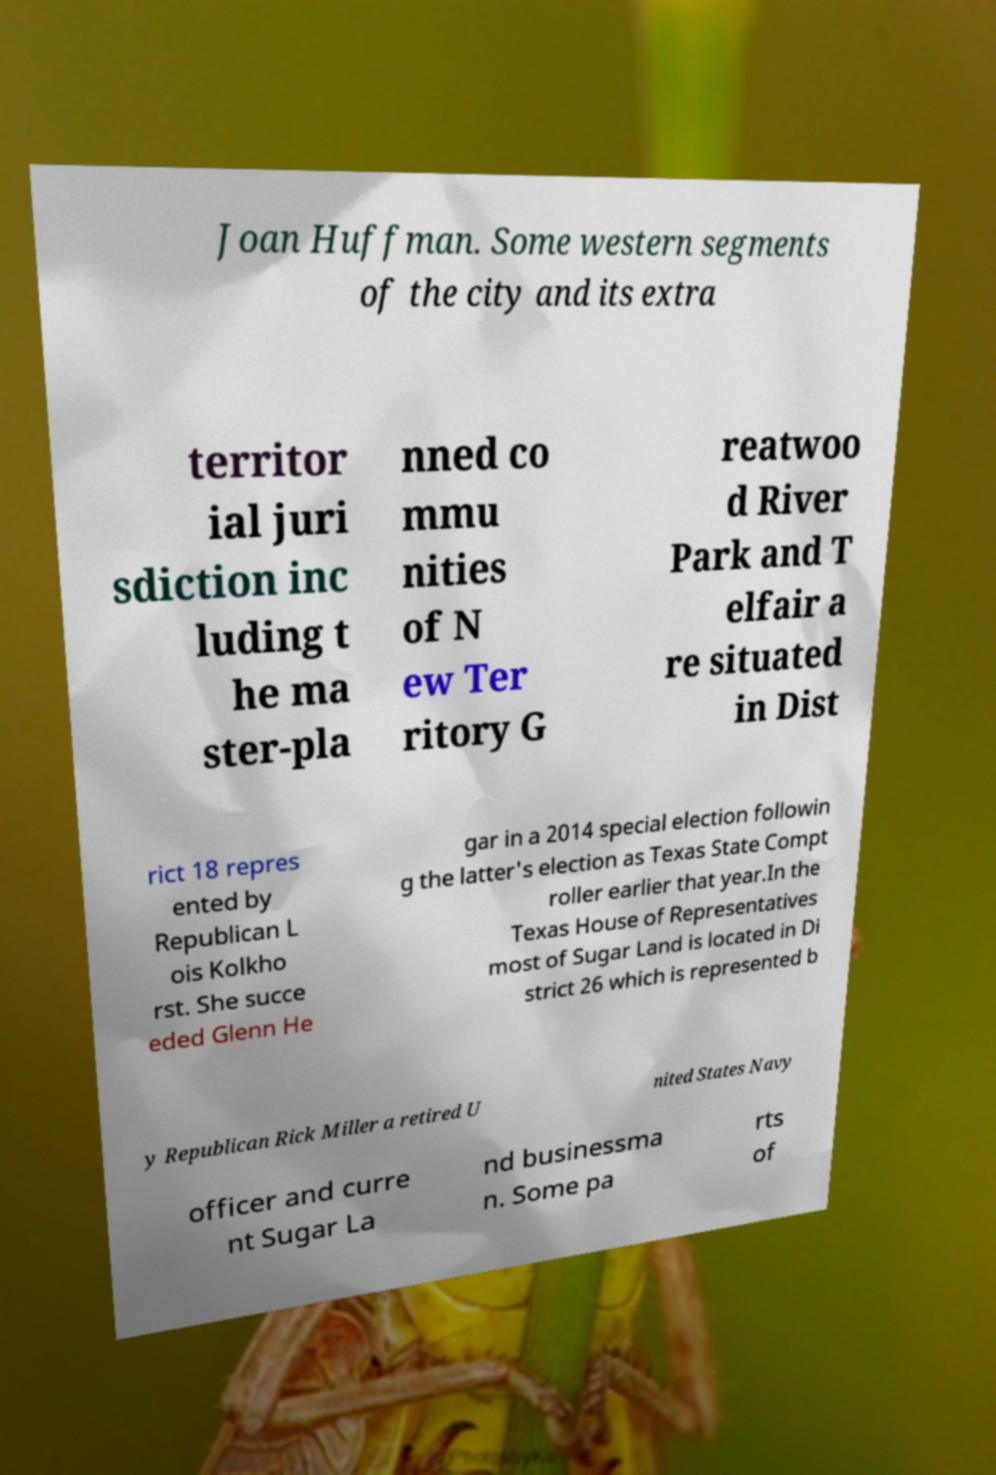Can you read and provide the text displayed in the image?This photo seems to have some interesting text. Can you extract and type it out for me? Joan Huffman. Some western segments of the city and its extra territor ial juri sdiction inc luding t he ma ster-pla nned co mmu nities of N ew Ter ritory G reatwoo d River Park and T elfair a re situated in Dist rict 18 repres ented by Republican L ois Kolkho rst. She succe eded Glenn He gar in a 2014 special election followin g the latter's election as Texas State Compt roller earlier that year.In the Texas House of Representatives most of Sugar Land is located in Di strict 26 which is represented b y Republican Rick Miller a retired U nited States Navy officer and curre nt Sugar La nd businessma n. Some pa rts of 